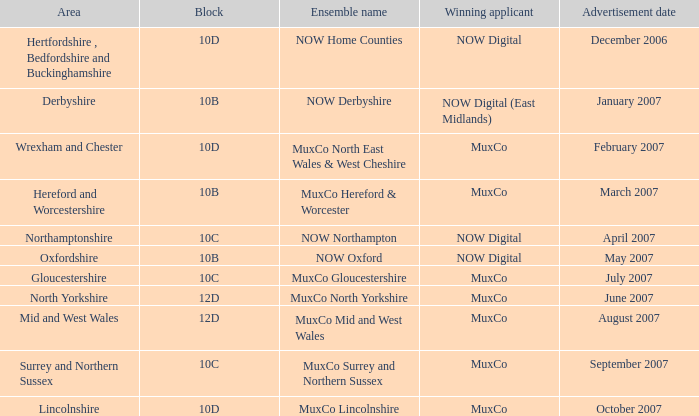Who is the Winning Applicant of Ensemble Name Muxco Lincolnshire in Block 10D? MuxCo. 